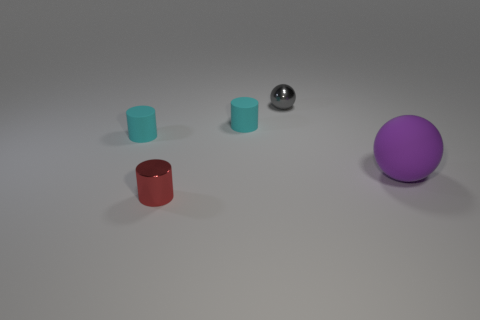The small matte object that is in front of the rubber cylinder to the right of the small red cylinder is what color?
Ensure brevity in your answer.  Cyan. Does the gray object have the same size as the purple matte ball?
Your response must be concise. No. There is a matte object that is both on the right side of the tiny metallic cylinder and on the left side of the purple sphere; what is its color?
Keep it short and to the point. Cyan. How big is the red thing?
Offer a terse response. Small. There is a small object that is left of the metallic cylinder; is it the same color as the shiny cylinder?
Ensure brevity in your answer.  No. Is the number of small red metallic cylinders in front of the red cylinder greater than the number of cyan cylinders behind the tiny ball?
Your answer should be compact. No. Are there more purple matte spheres than tiny brown cylinders?
Give a very brief answer. Yes. There is a matte object that is on the left side of the large purple rubber sphere and right of the tiny red object; what is its size?
Make the answer very short. Small. What is the shape of the small gray thing?
Your answer should be compact. Sphere. Is there anything else that is the same size as the rubber sphere?
Ensure brevity in your answer.  No. 